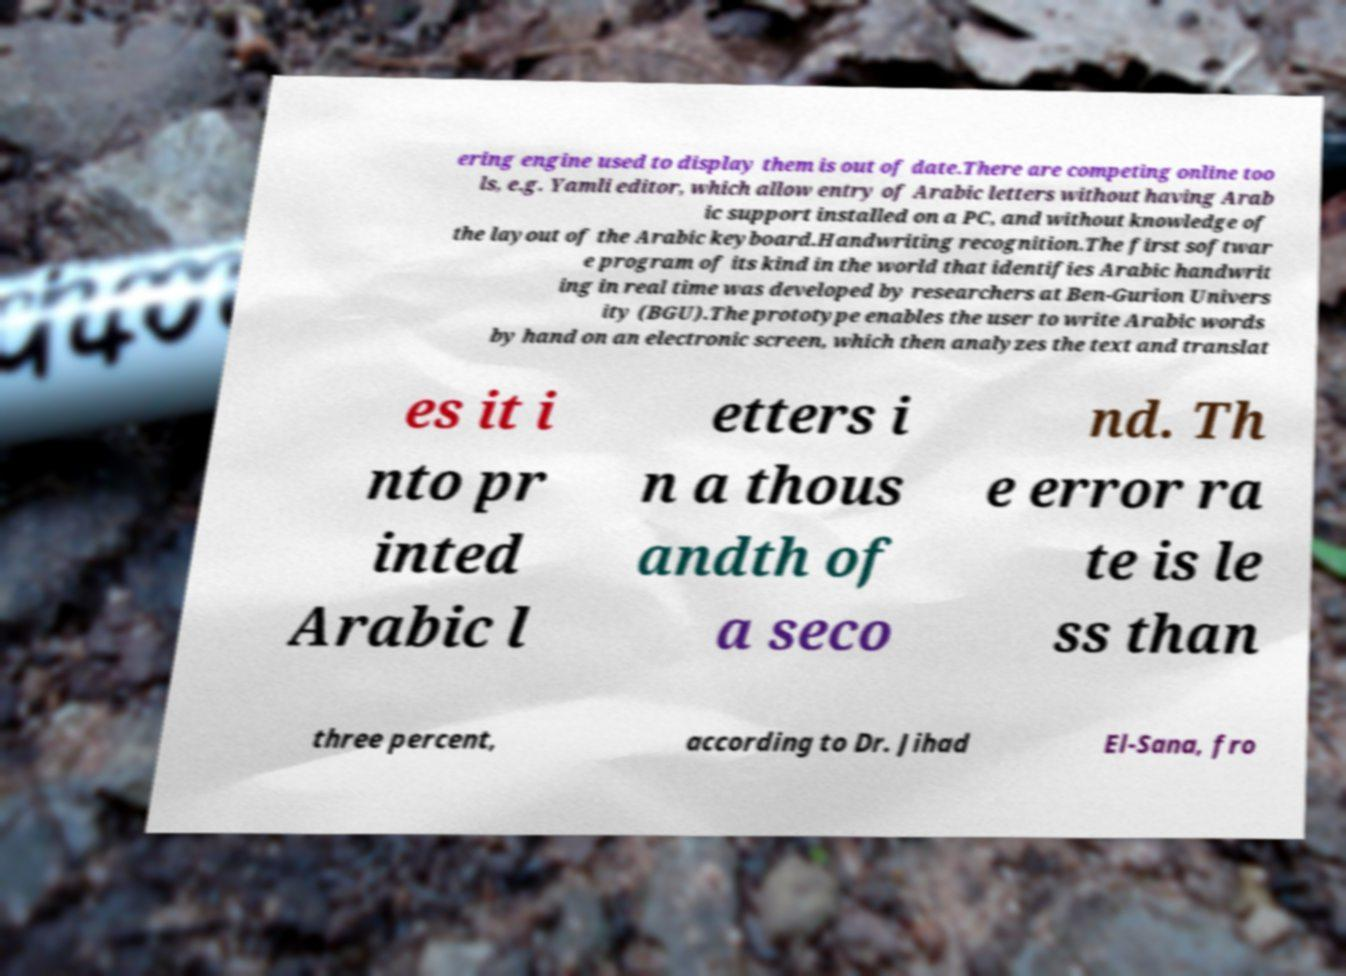Please identify and transcribe the text found in this image. ering engine used to display them is out of date.There are competing online too ls, e.g. Yamli editor, which allow entry of Arabic letters without having Arab ic support installed on a PC, and without knowledge of the layout of the Arabic keyboard.Handwriting recognition.The first softwar e program of its kind in the world that identifies Arabic handwrit ing in real time was developed by researchers at Ben-Gurion Univers ity (BGU).The prototype enables the user to write Arabic words by hand on an electronic screen, which then analyzes the text and translat es it i nto pr inted Arabic l etters i n a thous andth of a seco nd. Th e error ra te is le ss than three percent, according to Dr. Jihad El-Sana, fro 